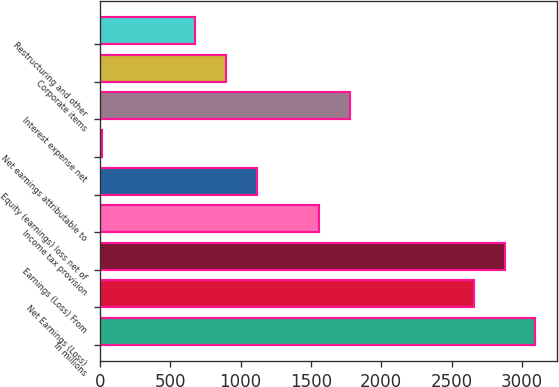Convert chart. <chart><loc_0><loc_0><loc_500><loc_500><bar_chart><fcel>In millions<fcel>Net Earnings (Loss)<fcel>Earnings (Loss) From<fcel>Income tax provision<fcel>Equity (earnings) loss net of<fcel>Net earnings attributable to<fcel>Interest expense net<fcel>Corporate items<fcel>Restructuring and other<nl><fcel>3096.8<fcel>2656.4<fcel>2876.6<fcel>1555.4<fcel>1115<fcel>14<fcel>1775.6<fcel>894.8<fcel>674.6<nl></chart> 